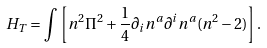Convert formula to latex. <formula><loc_0><loc_0><loc_500><loc_500>H _ { T } = \int \left [ n ^ { 2 } \Pi ^ { 2 } + \frac { 1 } { 4 } \partial _ { i } n ^ { a } \partial ^ { i } n ^ { a } ( n ^ { 2 } - 2 ) \right ] .</formula> 